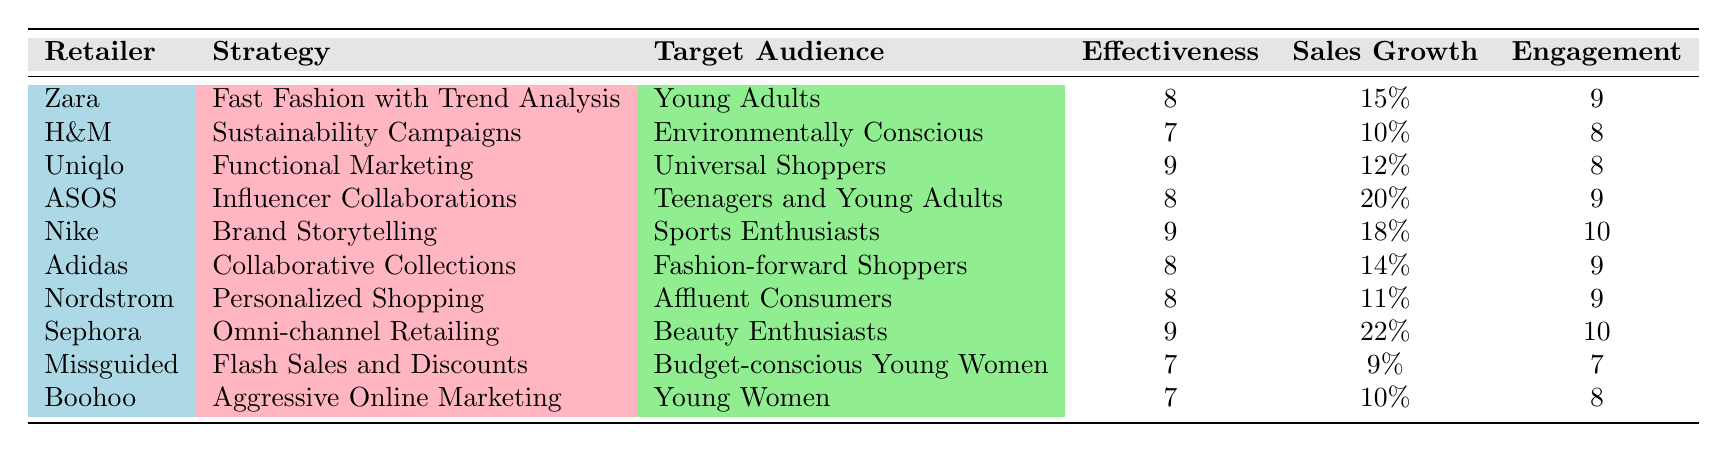What is the effectiveness rating of ASOS? In the table, I locate the row for ASOS and check the corresponding effectiveness rating, which is clearly noted in the respective column.
Answer: 8 Which retailer has the highest customer engagement score? By scanning through the customer engagement scores across all retailers, I identify that Nike has a score of 10, which is the highest among all listed.
Answer: Nike What is the average sales growth of all retailers listed in the table? To find the average sales growth, I first list the sales growth percentages from each retailer: 15, 10, 12, 20, 18, 14, 11, 22, 9, and 10. Then, I sum these values (15 + 10 + 12 + 20 + 18 + 14 + 11 + 22 + 9 + 10 =  141). Finally, I divide the sum by the number of retailers (141/10 = 14.1).
Answer: 14.1 Does H&M have a higher effectiveness rating than Missguided? I look at the effectiveness ratings for both H&M and Missguided in the table. H&M has a rating of 7, and Missguided also has a rating of 7. Since they are equal, the answer is no.
Answer: No Which strategies have an effectiveness rating of 8 or higher? I review the effectiveness ratings in the table and identify the strategies that meet this criterion. The effective strategies include: Fast Fashion with Trend Analysis, Influencer Collaborations, Brand Storytelling, Collaborative Collections, Personalized Shopping, Omni-channel Retailing, and Flash Sales.
Answer: Fast Fashion with Trend Analysis, Influencer Collaborations, Brand Storytelling, Collaborative Collections, Personalized Shopping, Omni-channel Retailing What is the total number of regions covered by all retailers? I will assess the regions for each retailer, listing them to avoid double counting. The unique regions mentioned are Europe, Asia, North America, Australia, and Global. Therefore, I count these unique entries, totaling five regions.
Answer: 5 Is Nike targeting affluent consumers with its marketing strategy? In the table, I first find Nike in the row and check the target audience listed. It states "Sports Enthusiasts," not affluent consumers. Thus, the answer is no.
Answer: No Which retailer experienced the highest average sales growth? I analyze the average sales growth percentages for all retailers in the table and find that Sephora has the highest at 22%.
Answer: Sephora 